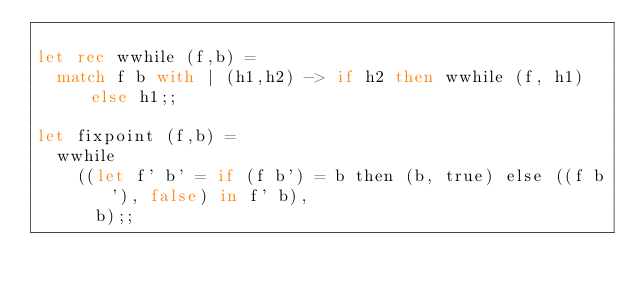<code> <loc_0><loc_0><loc_500><loc_500><_OCaml_>
let rec wwhile (f,b) =
  match f b with | (h1,h2) -> if h2 then wwhile (f, h1) else h1;;

let fixpoint (f,b) =
  wwhile
    ((let f' b' = if (f b') = b then (b, true) else ((f b'), false) in f' b),
      b);;
</code> 